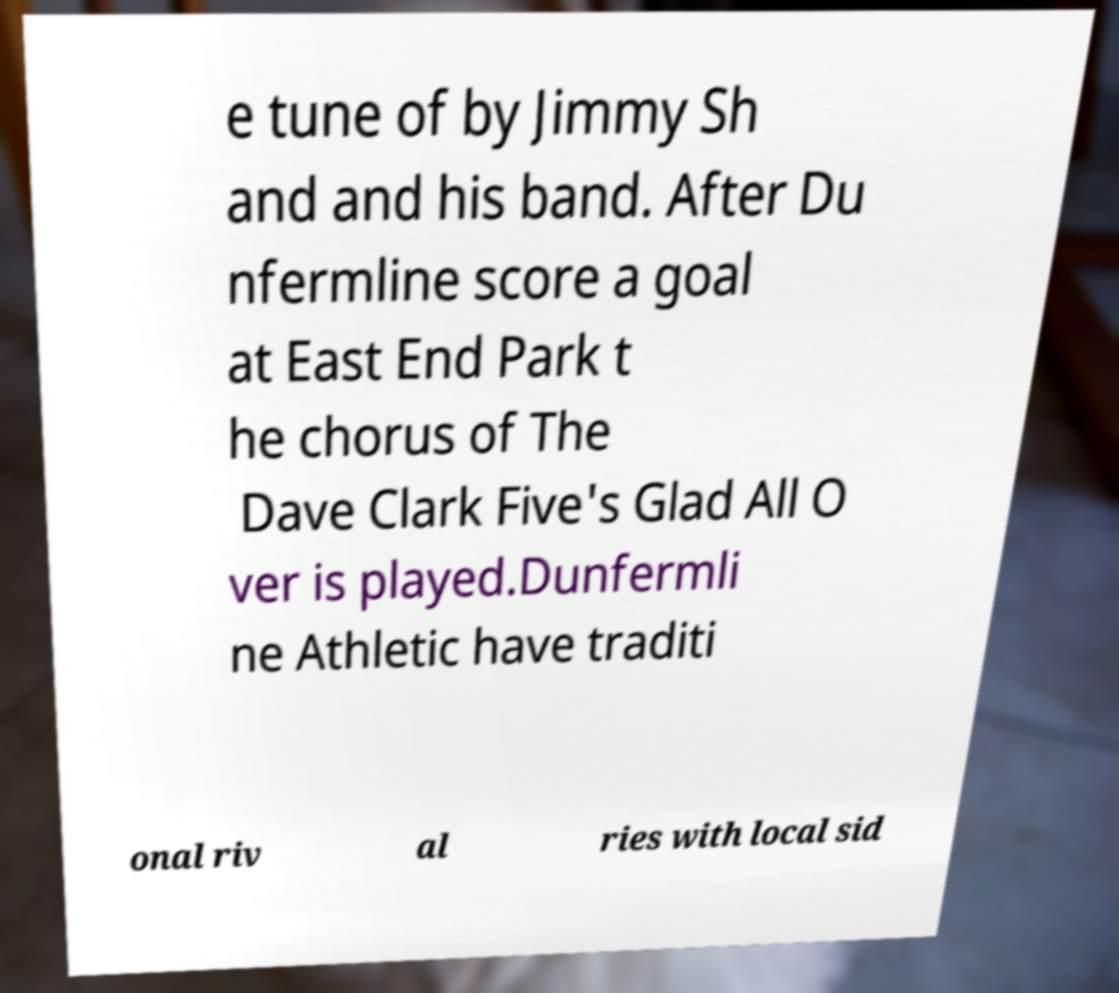Could you extract and type out the text from this image? e tune of by Jimmy Sh and and his band. After Du nfermline score a goal at East End Park t he chorus of The Dave Clark Five's Glad All O ver is played.Dunfermli ne Athletic have traditi onal riv al ries with local sid 